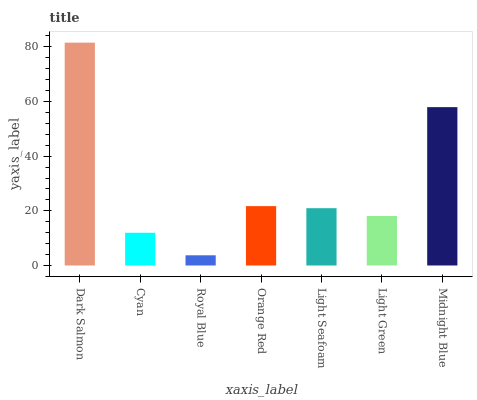Is Royal Blue the minimum?
Answer yes or no. Yes. Is Dark Salmon the maximum?
Answer yes or no. Yes. Is Cyan the minimum?
Answer yes or no. No. Is Cyan the maximum?
Answer yes or no. No. Is Dark Salmon greater than Cyan?
Answer yes or no. Yes. Is Cyan less than Dark Salmon?
Answer yes or no. Yes. Is Cyan greater than Dark Salmon?
Answer yes or no. No. Is Dark Salmon less than Cyan?
Answer yes or no. No. Is Light Seafoam the high median?
Answer yes or no. Yes. Is Light Seafoam the low median?
Answer yes or no. Yes. Is Dark Salmon the high median?
Answer yes or no. No. Is Light Green the low median?
Answer yes or no. No. 